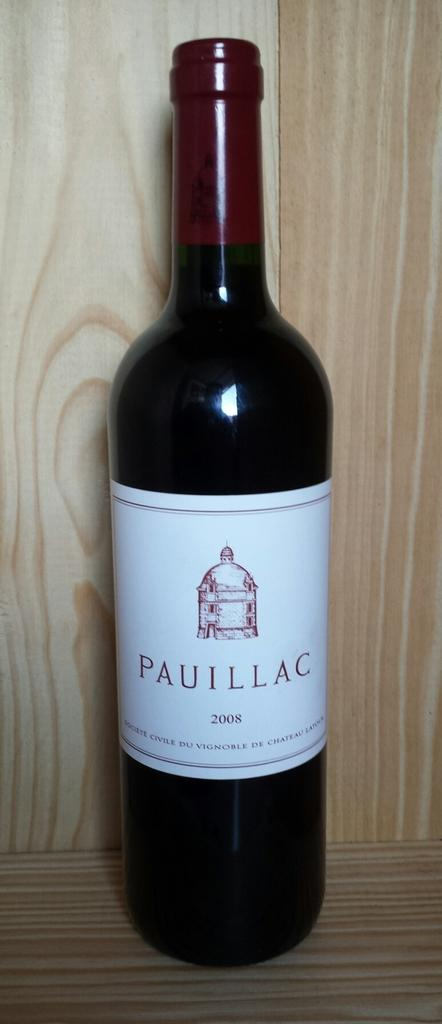<image>
Summarize the visual content of the image. A bottle of 2008 Pauillac is shown upright. 